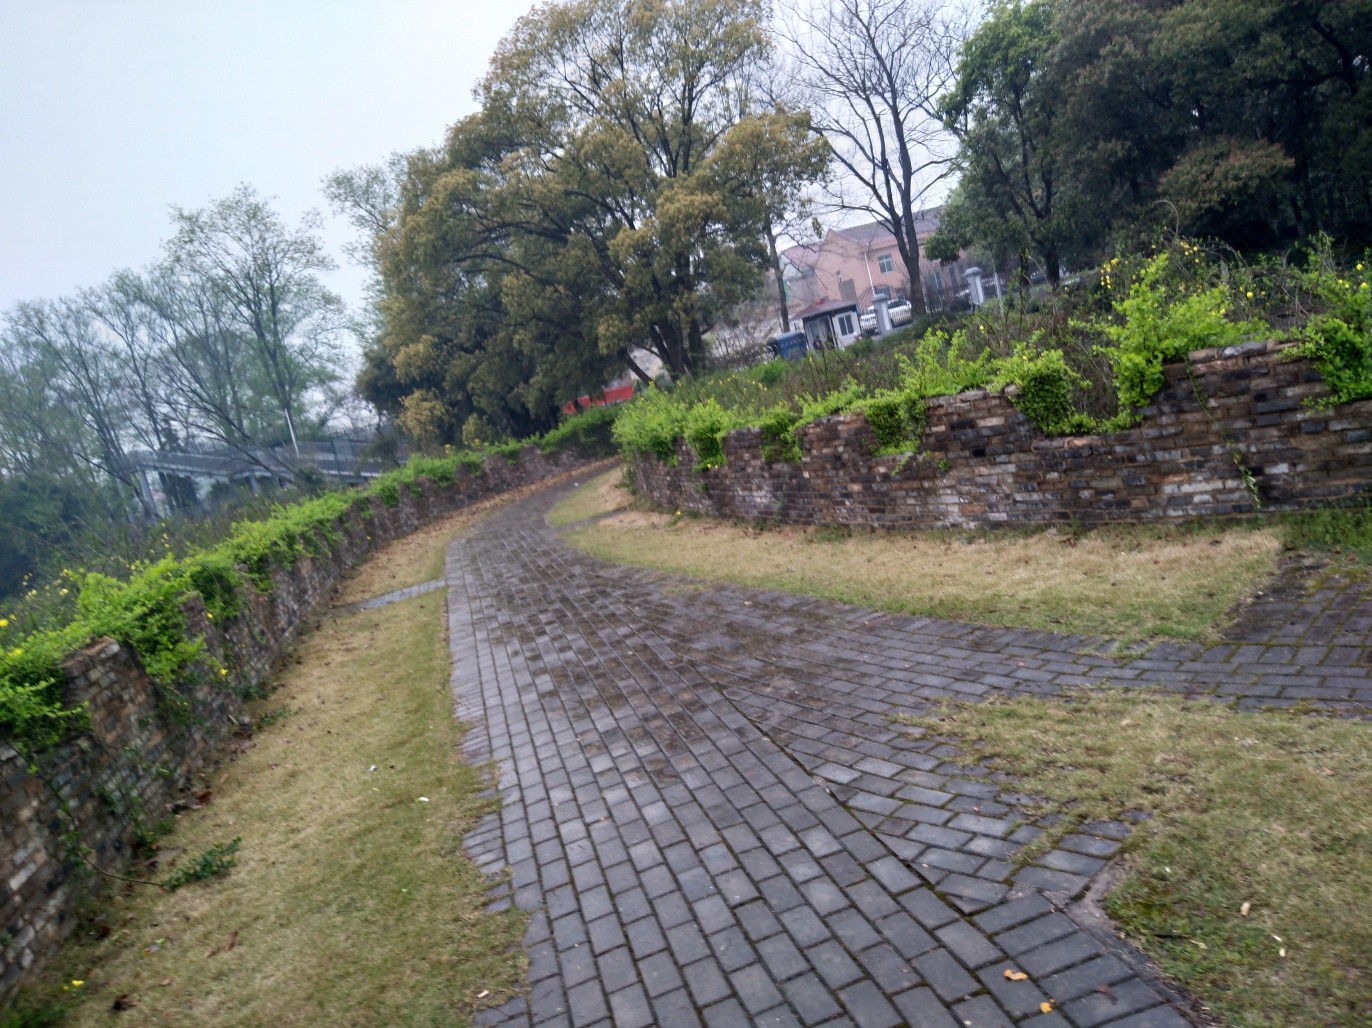Is the composition decent? The composition of the image is fairly well balanced with a clear path leading through the scene, creating a sense of depth. The foliage on either side adds a natural frame to the cobblestone pathway, while the overcast sky gives the image a moody ambiance. However, it could be improved by following the rule of thirds more closely and possibly adjusting the angle to highlight a specific focal point. 